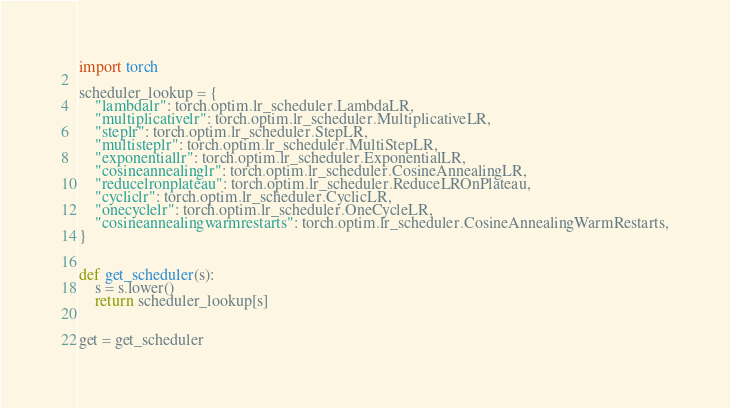<code> <loc_0><loc_0><loc_500><loc_500><_Python_>import torch

scheduler_lookup = {
    "lambdalr": torch.optim.lr_scheduler.LambdaLR,
    "multiplicativelr": torch.optim.lr_scheduler.MultiplicativeLR,
    "steplr": torch.optim.lr_scheduler.StepLR,
    "multisteplr": torch.optim.lr_scheduler.MultiStepLR,
    "exponentiallr": torch.optim.lr_scheduler.ExponentialLR,
    "cosineannealinglr": torch.optim.lr_scheduler.CosineAnnealingLR,
    "reducelronplateau": torch.optim.lr_scheduler.ReduceLROnPlateau,
    "cycliclr": torch.optim.lr_scheduler.CyclicLR,
    "onecyclelr": torch.optim.lr_scheduler.OneCycleLR,
    "cosineannealingwarmrestarts": torch.optim.lr_scheduler.CosineAnnealingWarmRestarts,
}


def get_scheduler(s):
    s = s.lower()
    return scheduler_lookup[s]


get = get_scheduler
</code> 